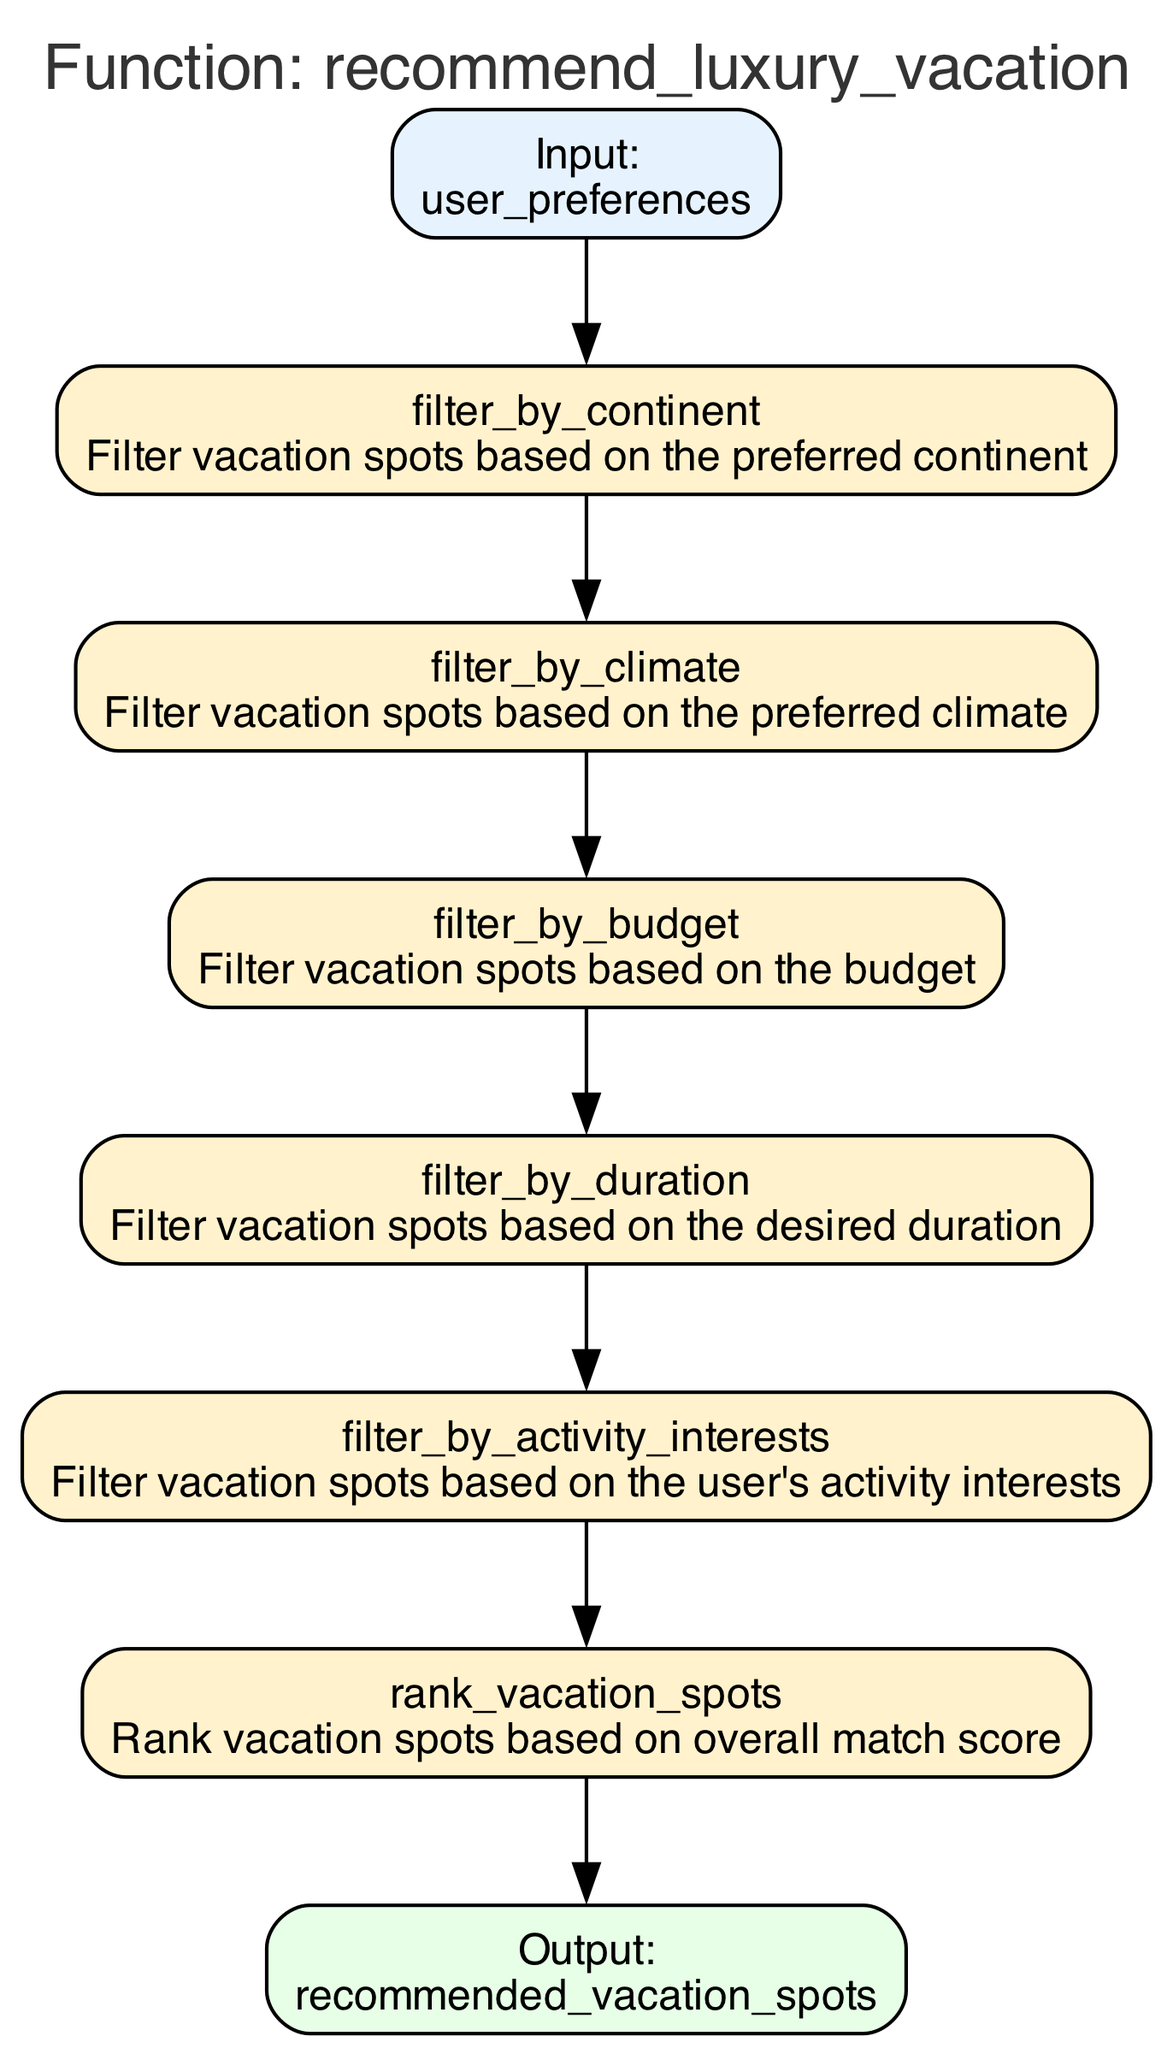What is the first step in the recommendation process? The first step in the diagram is labeled "filter_by_continent," which filters vacation spots based on the preferred continent.
Answer: filter_by_continent How many steps are in the recommendation process? The diagram contains six steps, as indicated by the enumeration of nodes from step_0 to step_5.
Answer: six What is the output of the function? The output node is labeled "recommended_vacation_spots," which indicates the destination where the results of the function lead.
Answer: recommended_vacation_spots Which parameter is used in the second step? The second step, "filter_by_climate," uses the parameter "preferred_climate" to filter vacation spots by climate preferences.
Answer: preferred_climate What is the connection between the last step and the output? The last step, "rank_vacation_spots," is directly connected to the output node, indicating that the ranking results lead to the recommended vacation spots.
Answer: direct connection Which step comes after filtering by budget? The step that comes after "filter_by_budget" is "filter_by_duration," indicating the order of the filtering process.
Answer: filter_by_duration How does the function rank the vacation spots? Vacation spots are ranked based on an overall match score computed in the "rank_vacation_spots" step after all filtering steps have been completed.
Answer: overall match score What type of data does the input node represent? The input node represents "user_preferences," which is a structured set of user preferences for the vacation recommendations.
Answer: user_preferences What is the purpose of the "filter_by_activity_interests" step? This step filters vacation spots according to the user's specified activity interests, ensuring the recommendations align with their desired activities.
Answer: filter vacation spots based on activity interests 